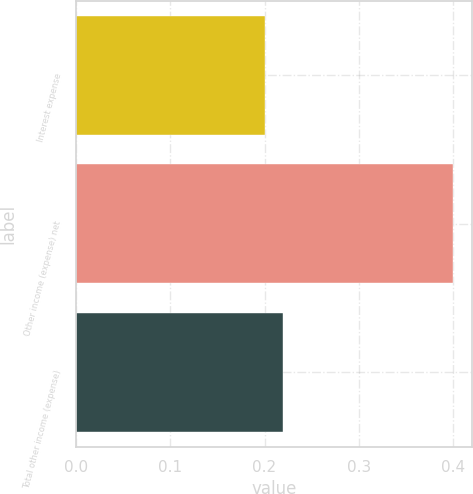<chart> <loc_0><loc_0><loc_500><loc_500><bar_chart><fcel>Interest expense<fcel>Other income (expense) net<fcel>Total other income (expense)<nl><fcel>0.2<fcel>0.4<fcel>0.22<nl></chart> 